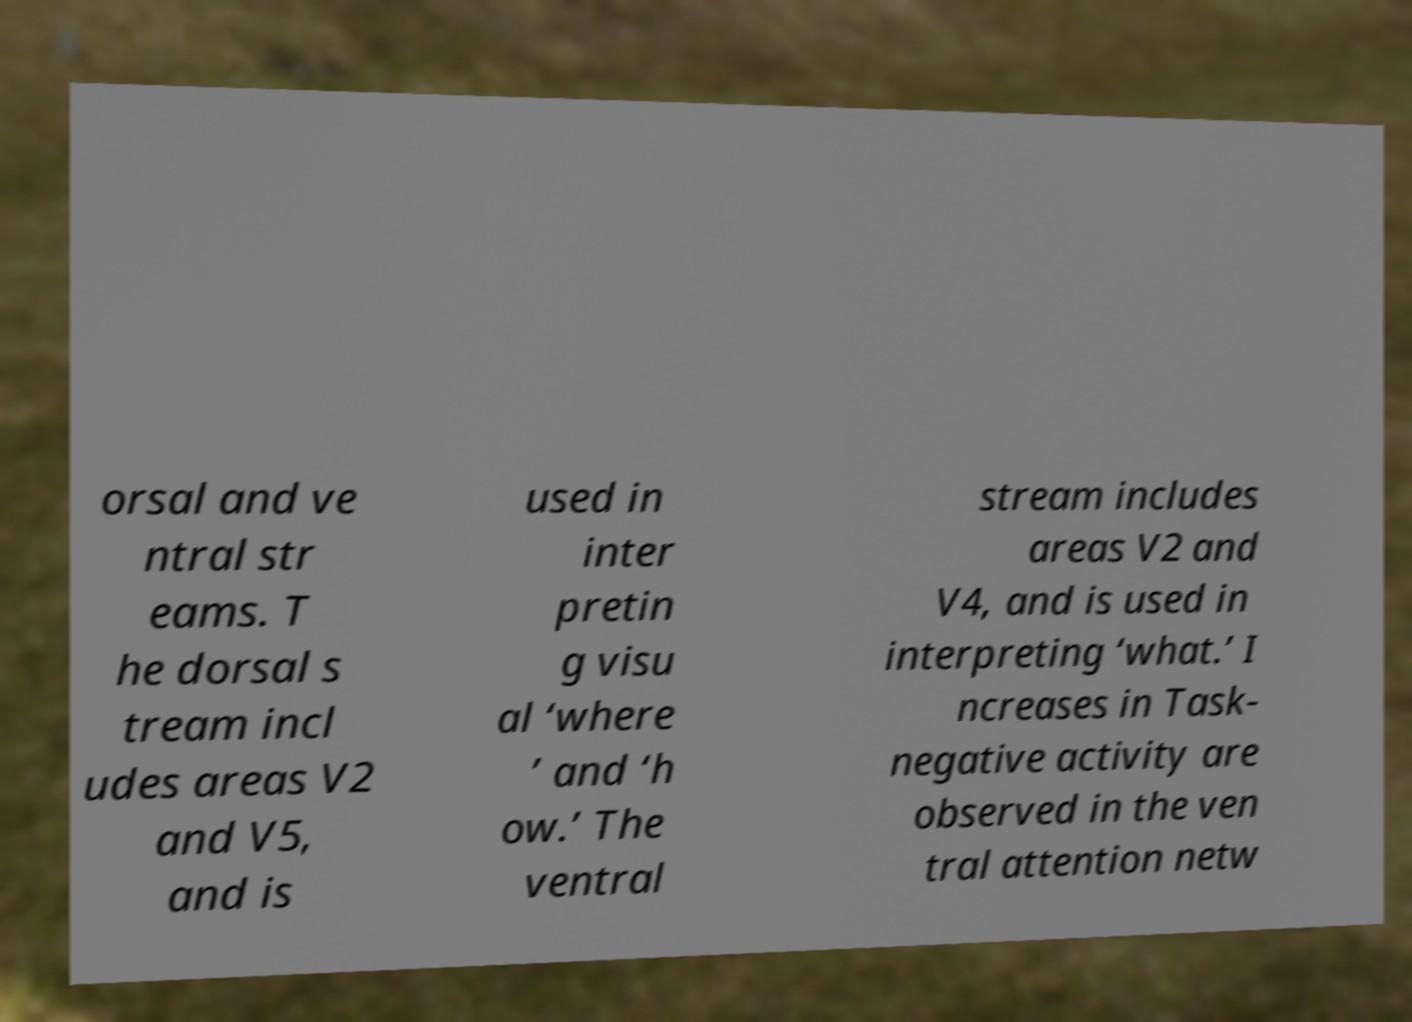There's text embedded in this image that I need extracted. Can you transcribe it verbatim? orsal and ve ntral str eams. T he dorsal s tream incl udes areas V2 and V5, and is used in inter pretin g visu al ‘where ’ and ‘h ow.’ The ventral stream includes areas V2 and V4, and is used in interpreting ‘what.’ I ncreases in Task- negative activity are observed in the ven tral attention netw 